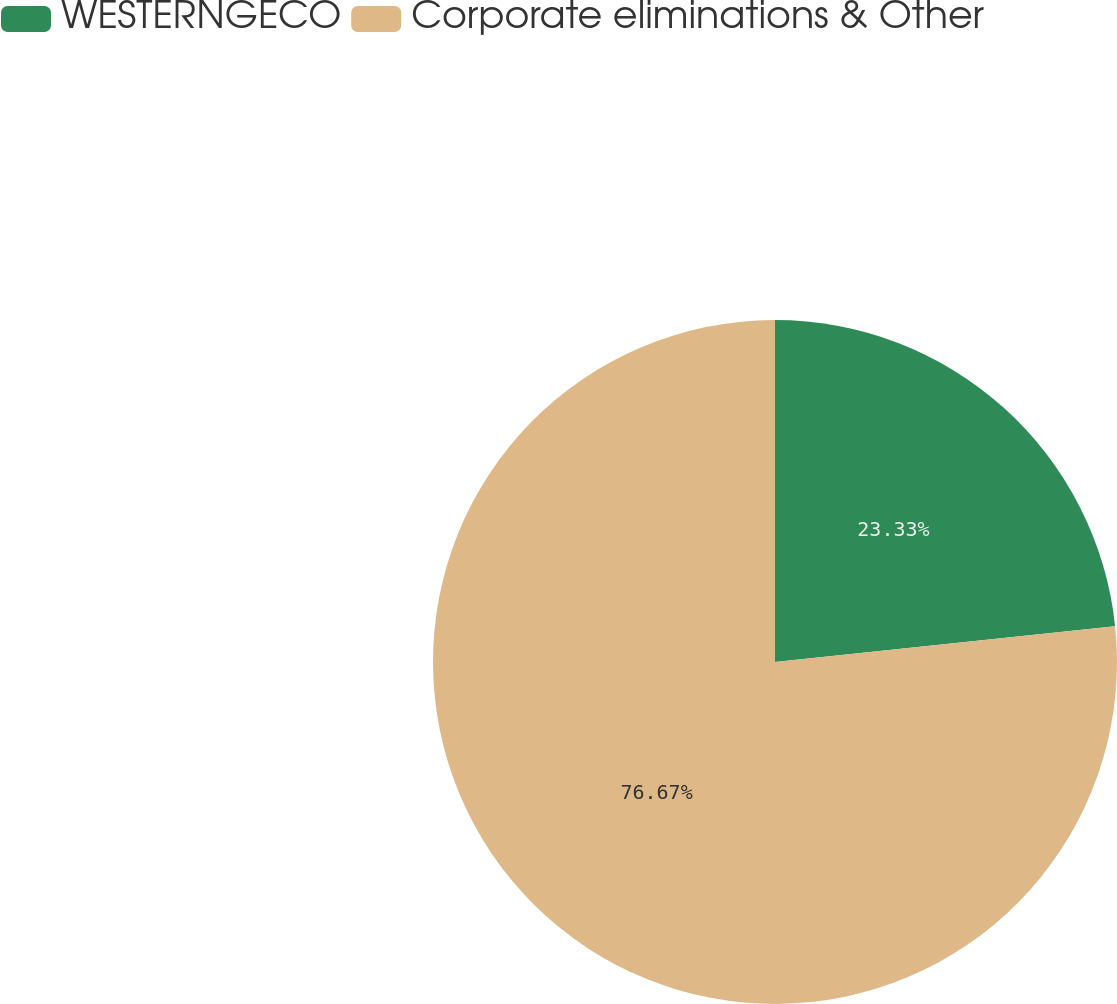Convert chart. <chart><loc_0><loc_0><loc_500><loc_500><pie_chart><fcel>WESTERNGECO<fcel>Corporate eliminations & Other<nl><fcel>23.33%<fcel>76.67%<nl></chart> 